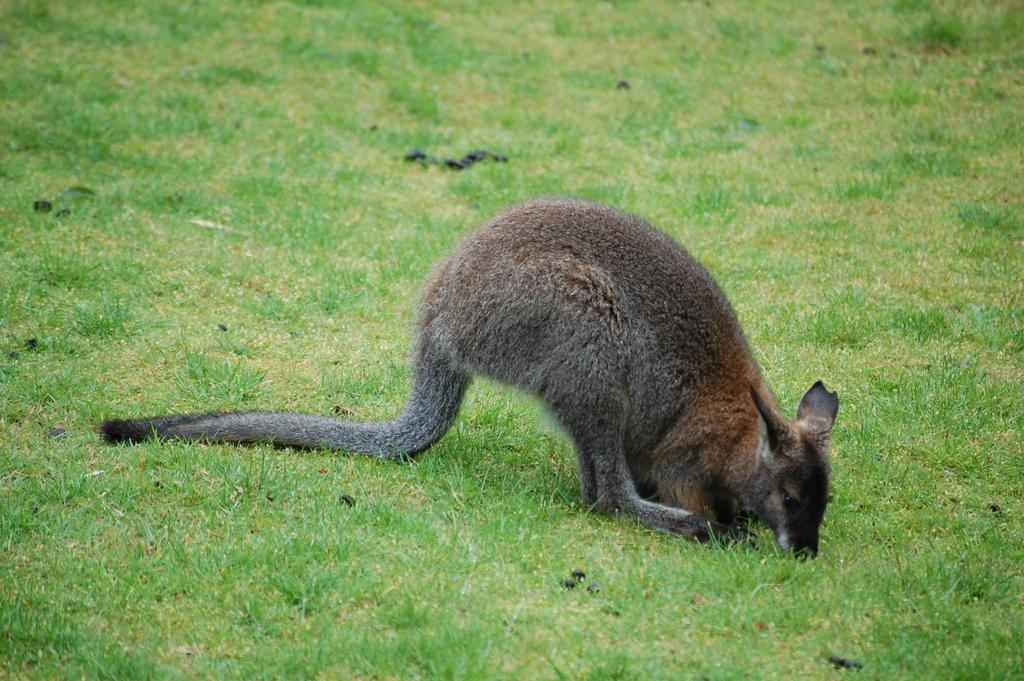What animal is present in the image? There is a kangaroo in the image. Where is the kangaroo located? The kangaroo is in a field. What type of patch can be seen on the kangaroo's back in the image? There is no patch visible on the kangaroo's back in the image. Can you see a zebra grazing next to the kangaroo in the field? There is no zebra present in the image; only a kangaroo is visible in the field. 